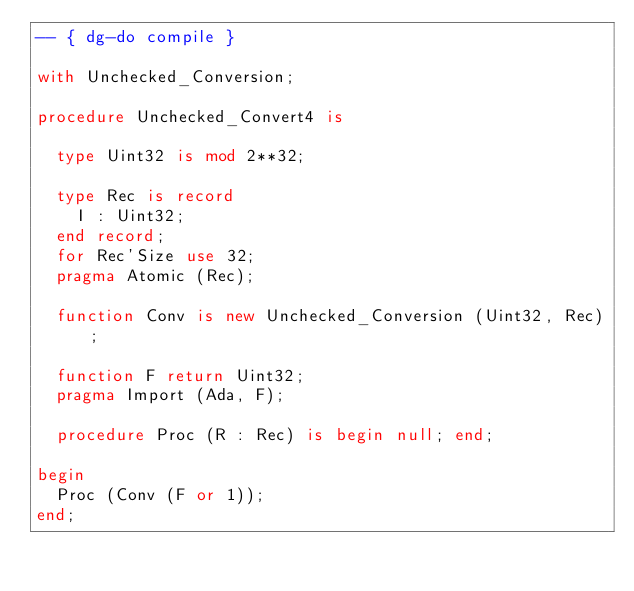Convert code to text. <code><loc_0><loc_0><loc_500><loc_500><_Ada_>-- { dg-do compile }

with Unchecked_Conversion;

procedure Unchecked_Convert4 is

  type Uint32 is mod 2**32;

  type Rec is record
    I : Uint32;
  end record;
  for Rec'Size use 32;
  pragma Atomic (Rec);

  function Conv is new Unchecked_Conversion (Uint32, Rec);

  function F return Uint32;
  pragma Import (Ada, F);

  procedure Proc (R : Rec) is begin null; end;

begin
  Proc (Conv (F or 1));
end;
</code> 